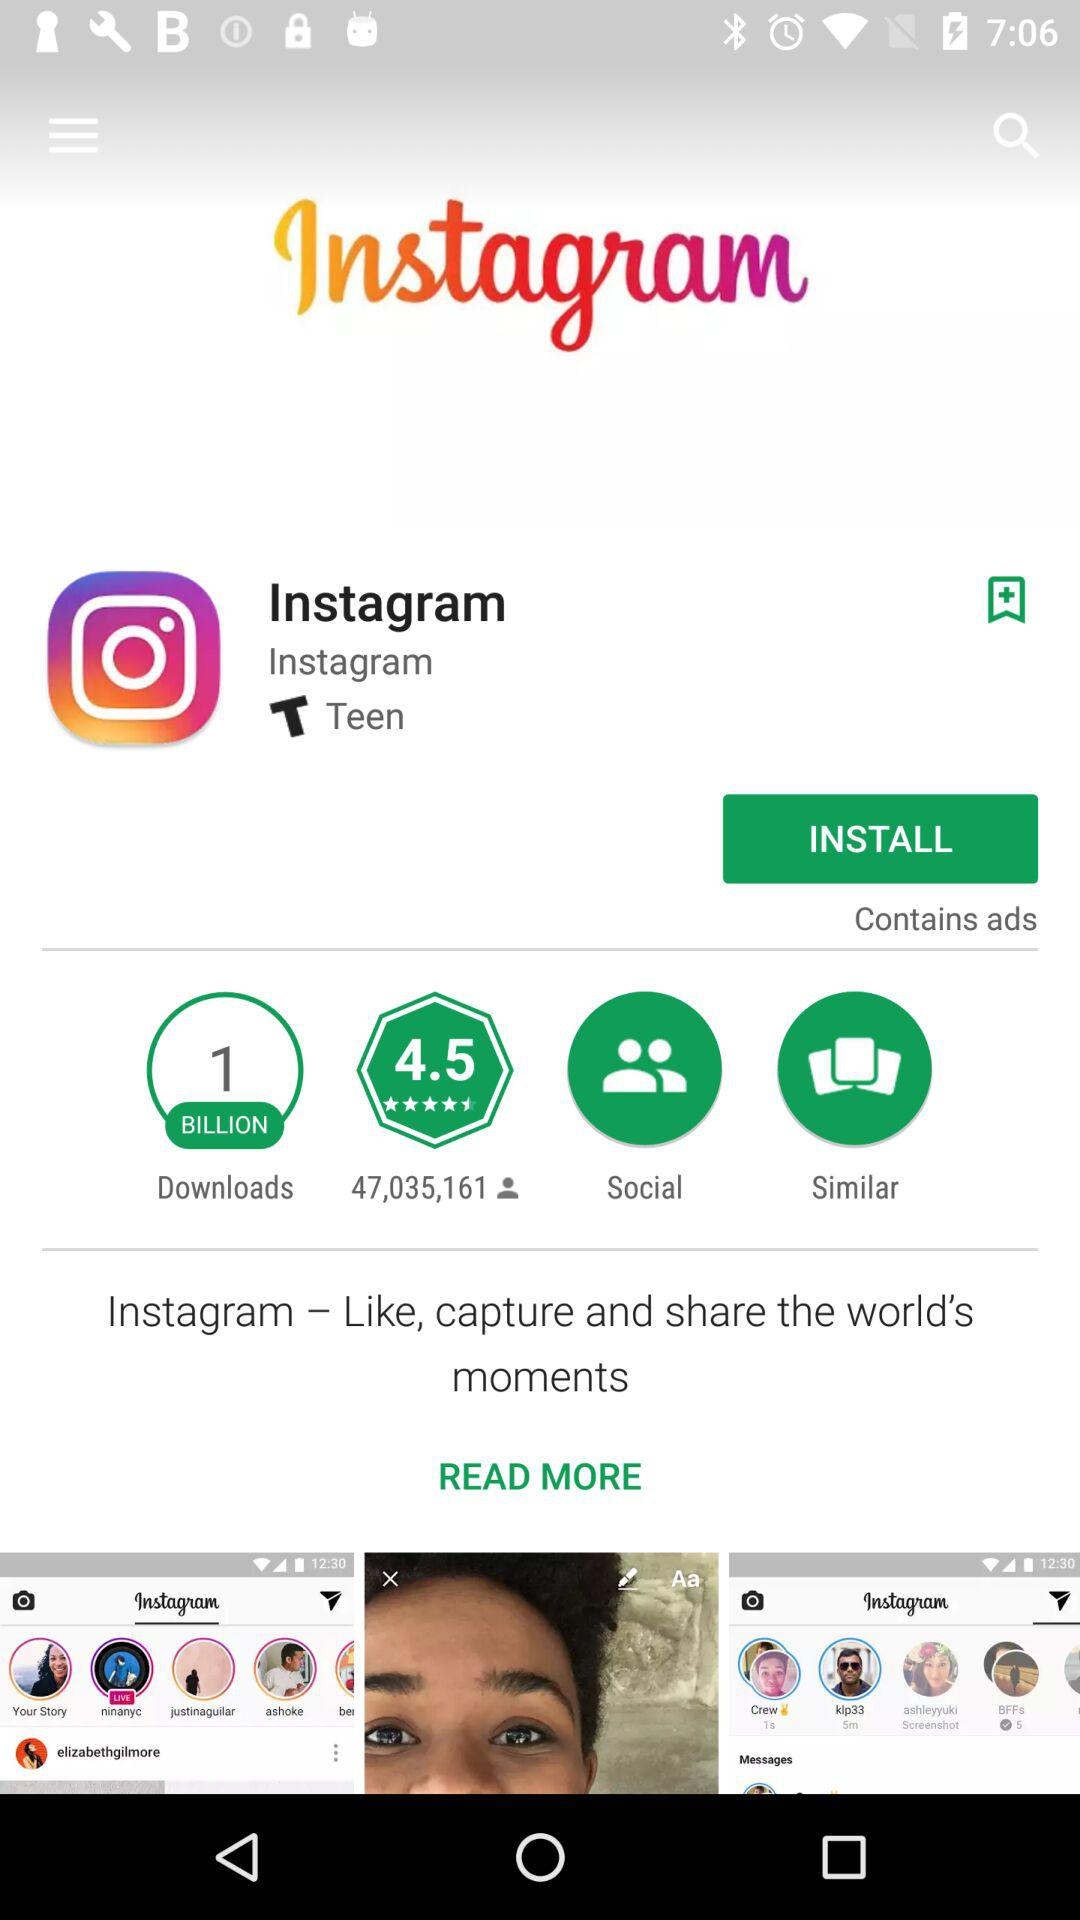How many people downloaded the application? There were 1 billion people who downloaded the application. 